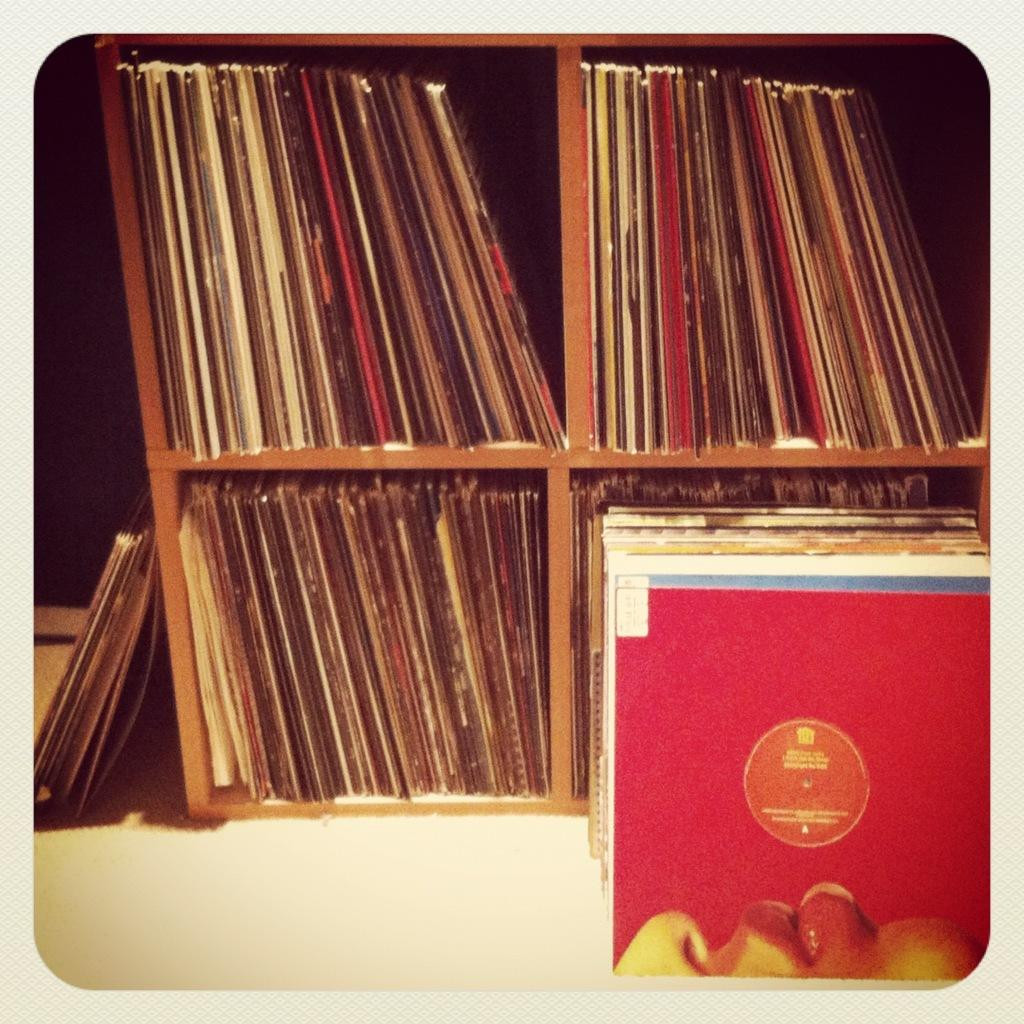What objects are visible in the image? There are many books in the image. How are the books arranged in the image? The books are kept in shelves. What type of bell can be heard ringing in the image? There is no bell present in the image, and therefore no sound can be heard. 